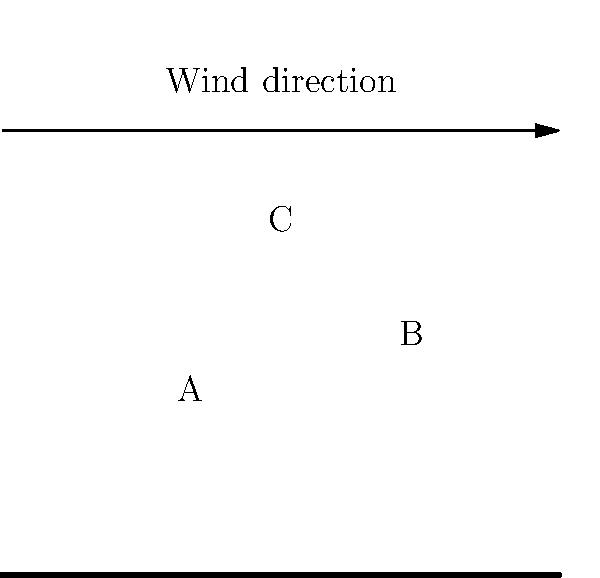Based on the satellite image of cloud formations near the Yucatan Peninsula, which cloud cluster (A, B, or C) is most likely to develop into a stronger storm that could potentially disrupt outdoor activities? To determine which cloud cluster is most likely to develop into a stronger storm, we need to consider several factors:

1. Size: Larger cloud clusters generally have more potential for storm development.
   - Cloud A is the smallest
   - Cloud B is medium-sized
   - Cloud C is the largest

2. Position relative to wind direction: Clouds moving with the wind tend to grow and intensify.
   - The wind is moving from left to right (west to east)
   - Cloud C is positioned to move with the wind more than A or B

3. Proximity to the coast: Storms often intensify as they approach land due to increased friction and moisture.
   - Cloud C is furthest from the coast, giving it more time to develop over water

4. Shape: More organized, circular shapes often indicate stronger storm potential.
   - Cloud C appears to be the most circular and organized

5. Density: Denser, whiter clouds often indicate more intense convection.
   - Cloud C appears to be the densest and whitest

Considering all these factors, Cloud C has the highest potential for developing into a stronger storm:
- It's the largest
- It's positioned to move with the prevailing winds
- It has more time over water to intensify
- It has a more organized, circular shape
- It appears to be the densest

Therefore, Cloud C is most likely to develop into a stronger storm that could potentially disrupt outdoor activities near the Yucatan Peninsula.
Answer: C 